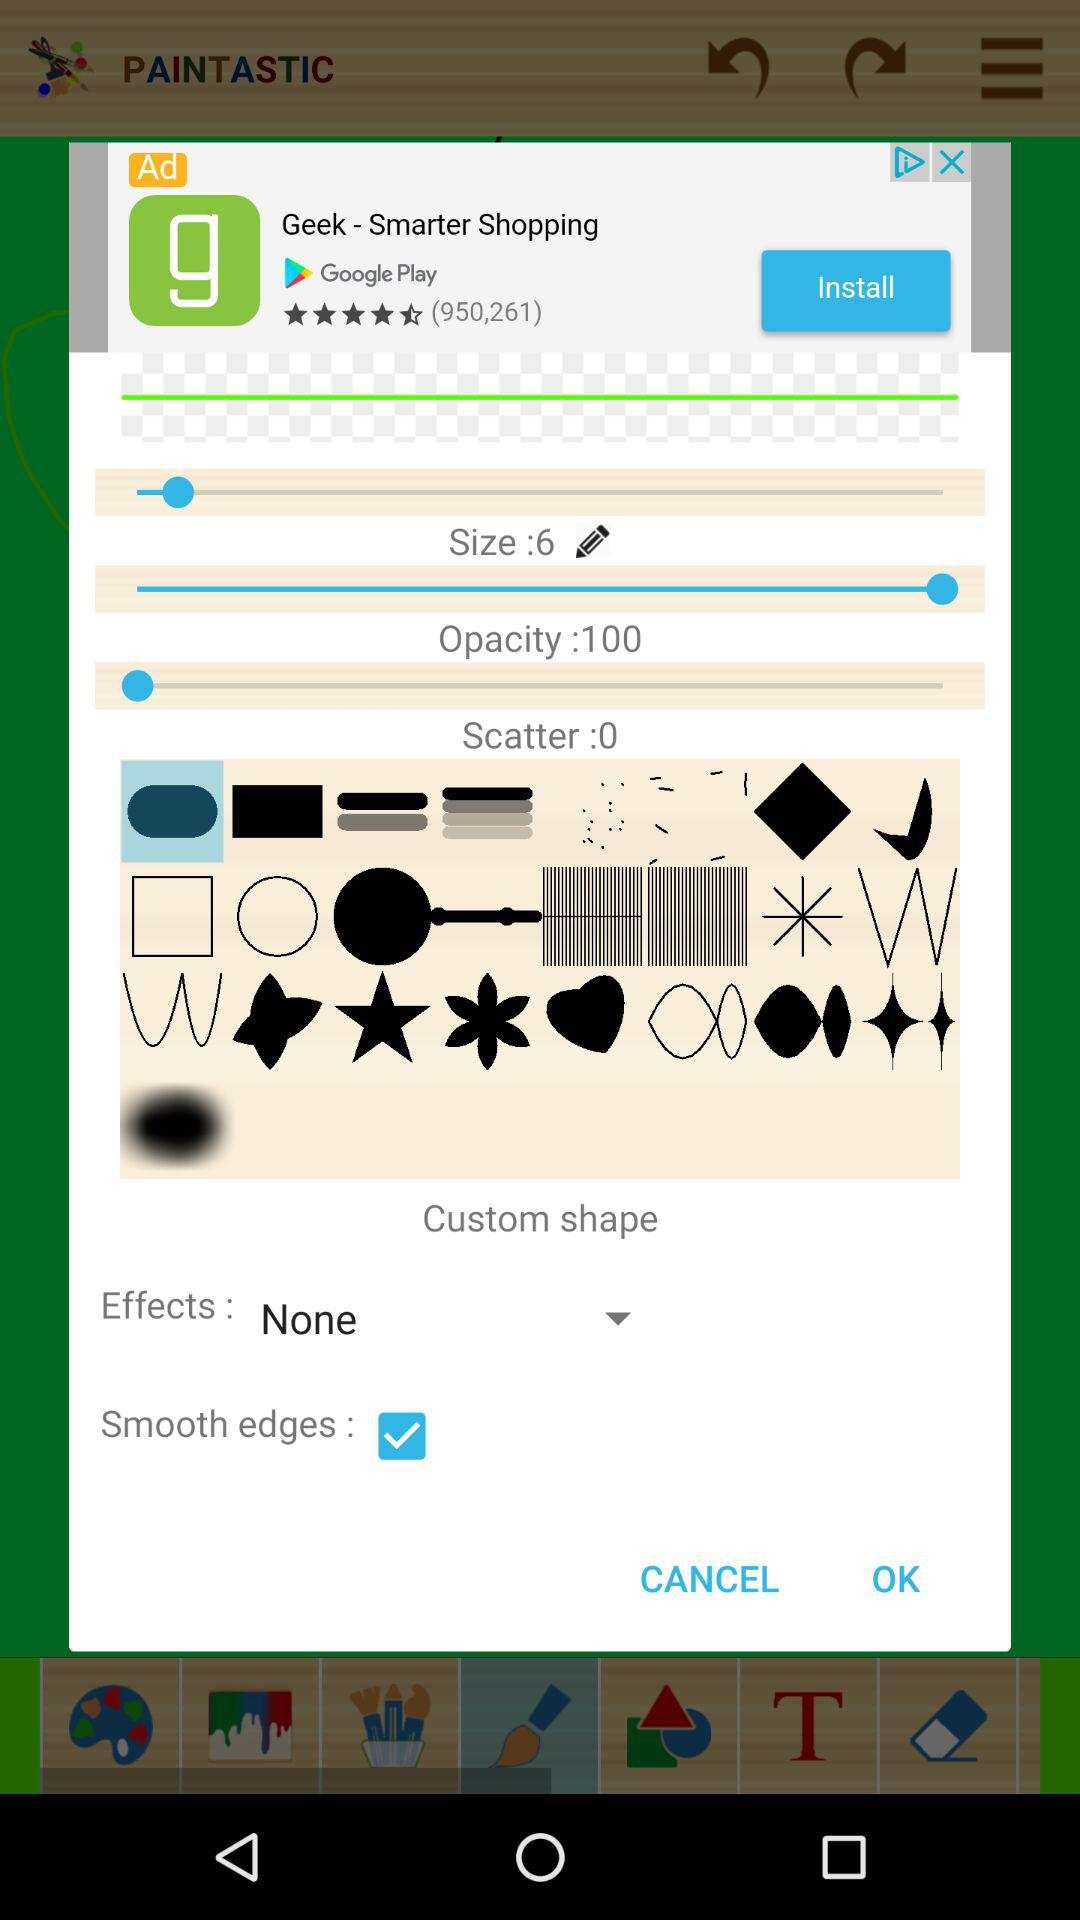What is the opacity? The opacity is 100. 